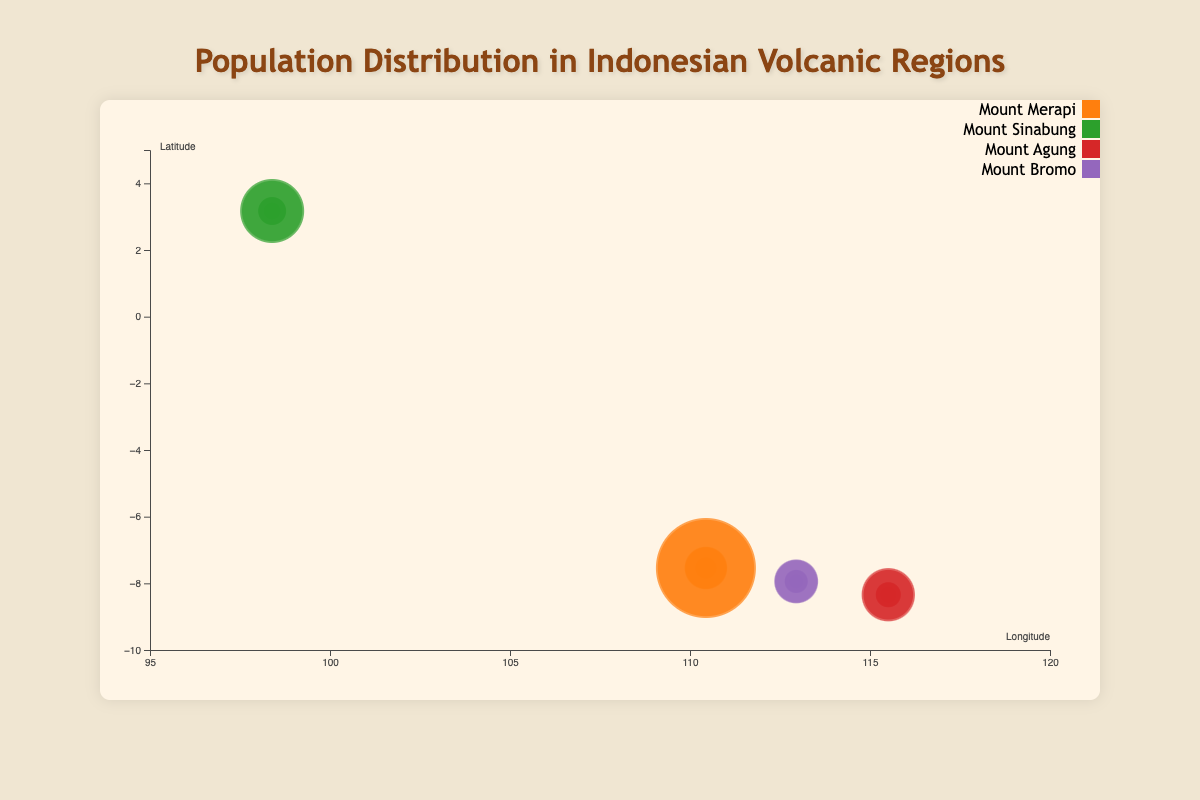How many total data points are represented in the bubble chart? To determine the total number of data points, count each circle individually, which represent combinations of region, gender, and age group. There are 24 circles in total.
Answer: 24 Which region has the highest population in the age group 15-64? By examining the size of the circles corresponding to the age group 15-64 across all regions, the largest circles are in Mount Merapi for both male and female.
Answer: Mount Merapi What is the approximate longitude and latitude where the population density is highest for the 0-14 age group? For the 0-14 age group, the largest circles are in the Mount Merapi region, with latitude around -7.54 and longitude around 110.442.
Answer: Longitude: 110.442, Latitude: -7.54 Compare the population of males aged 65+ in Mount Sinabung and Mount Agung. Which is higher, and by how much? The population of males aged 65+ in Mount Sinabung is 9000. In Mount Agung, it is 8000. The population in Mount Sinabung is higher by 1000.
Answer: Mount Sinabung by 1000 Which gender has a higher population in Mount Bromo for the age group 15-64? For the age group 15-64 in Mount Bromo, the population of females (47000) is higher than that of males (45000).
Answer: Female What is the total population of females aged 0-14 across all regions? Sum the populations of females aged 0-14 across all regions: 43000 (Mount Merapi) + 24000 (Mount Sinabung) + 20000 (Mount Agung) + 17500 (Mount Bromo) = 104500.
Answer: 104500 In which region do males aged 0-14 have the smallest population, and what is that population? Compare the populations of males aged 0-14 across all regions: Mount Merapi (45000), Mount Sinabung (25000), Mount Agung (21000), and Mount Bromo (18000). Mount Bromo has the smallest population, which is 18000.
Answer: Mount Bromo, 18000 For the age group 65+, which region has the smallest overall population, and what is the combined population of males and females in that region? Look at the populations for both genders aged 65+ in all regions. In Mount Bromo, males have 5500 and females have 5900, giving a total of 11400. This is the smallest combined population for this age group.
Answer: Mount Bromo, 11400 What is the average population of males in the age group 15-64 across all regions? Calculate the total population of males aged 15-64 across all regions and then divide by the number of regions: (120000 + 70000 + 55000 + 45000) / 4 = 72500.
Answer: 72500 Which region has the highest total population for all genders and age groups combined? Sum the populations of all age groups and genders for each region. Mount Merapi: (45000+43000+120000+125000+15000+16000), Mount Sinabung: (25000+24000+70000+75000+9000+9500), Mount Agung: (21000+20000+55000+60000+8000+8500), Mount Bromo: (18000+17500+45000+47000+5500+5900). Mount Merapi has the highest population, totaling 364000.
Answer: Mount Merapi 